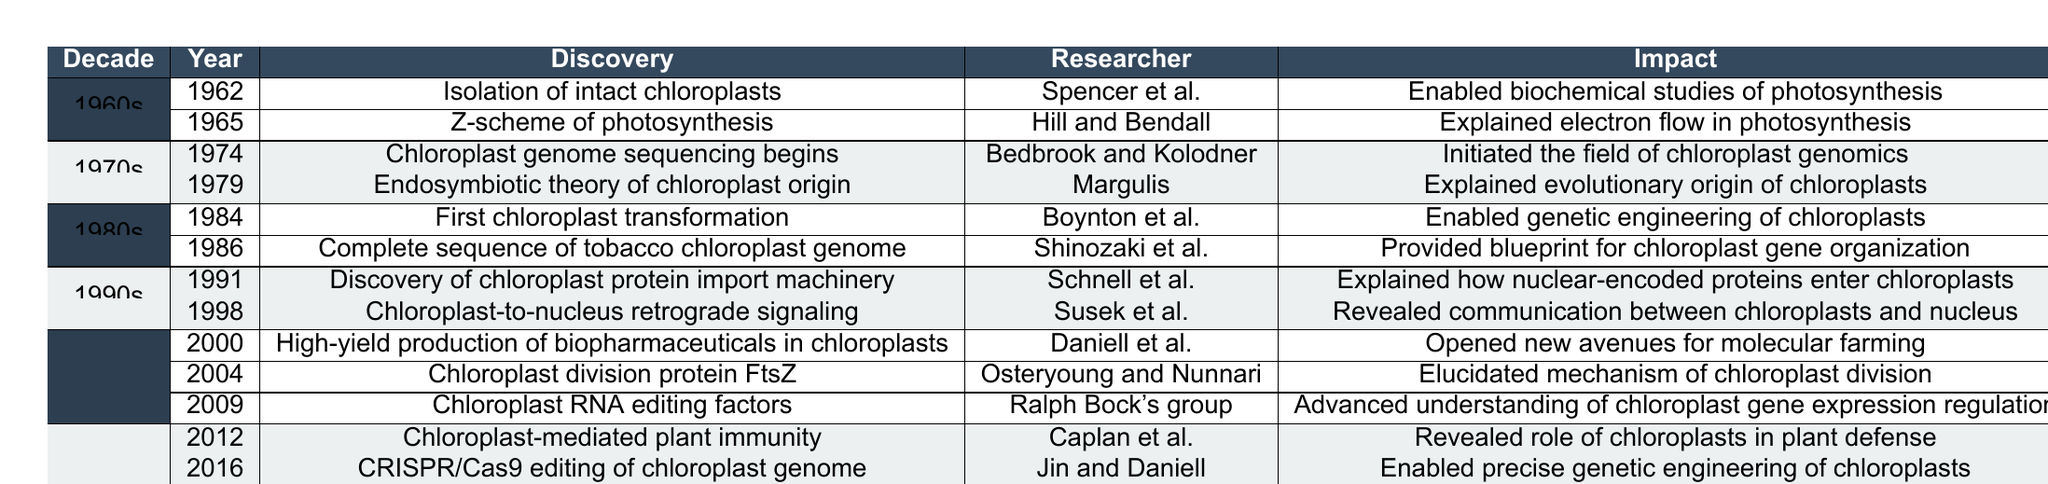What major discovery occurred in 1965 related to photosynthesis? The table lists that in 1965, the discovery of the "Z-scheme of photosynthesis" was made by Hill and Bendall. This discovery is significant as it explained electron flow in photosynthesis.
Answer: Z-scheme of photosynthesis Which researcher is associated with the first chloroplast transformation in 1984? Looking at the 1980s section of the table, the researcher associated with the first chloroplast transformation in 1984 is Boynton et al.
Answer: Boynton et al What was the impact of the discovery made in 1991? The 1991 discovery by Schnell et al. focused on the chloroplast protein import machinery, which explained how nuclear-encoded proteins enter chloroplasts.
Answer: Explained how nuclear-encoded proteins enter chloroplasts In which decade did chloroplast genome sequencing begin? According to the table, chloroplast genome sequencing began in the 1970s, specifically in the year 1974.
Answer: 1970s How many discoveries were made in the 2000s according to the table? In the 2000s section, there are three discoveries listed: 2000, 2004, and 2009. Therefore, the total number of discoveries made is 3.
Answer: 3 What is the relationship between the 2016 discovery and chloroplast genetic engineering? The 2016 discovery by Jin and Daniell involved "CRISPR/Cas9 editing of chloroplast genome," which enabled precise genetic engineering of chloroplasts. Hence, the relationship is that this discovery directly contributes to advances in genetic engineering.
Answer: Enables precise genetic engineering of chloroplasts Which discovery had the earliest impact according to the table? The table indicates that the discovery of "Isolation of intact chloroplasts" in 1962 by Spencer et al. had the earliest impact, enabling biochemical studies of photosynthesis.
Answer: Isolation of intact chloroplasts Between 1991 and 1998, which discovery had a broader implication in inter-organelle communication? The 1998 discovery of "Chloroplast-to-nucleus retrograde signaling" by Susek et al. had a broader implication in communication between chloroplasts and the nucleus compared to the 1991 discovery.
Answer: Chloroplast-to-nucleus retrograde signaling What is the significance of the "Synthetic chloroplast genome" discovery made in 2019? The 2019 discovery by Turmel et al. of a synthetic chloroplast genome opened possibilities for designing artificial chloroplasts, which has significant implications for synthetic biology and biotechnology.
Answer: Opened possibilities for designing artificial chloroplasts Was the discovery of the endosymbiotic theory of chloroplast origin confirmed by research in the 1970s? Yes, the table confirms that the "Endosymbiotic theory of chloroplast origin" was discovered by Margulis in 1979, confirming the evolutionary origin of chloroplasts.
Answer: Yes How does the impact of Ralph Bock's group's discovery in 2009 compare to the understanding of chloroplast genetics as a whole? The discovery in 2009 regarding "Chloroplast RNA editing factors" advanced the understanding of chloroplast gene expression regulation, which contributes to the overall understanding of chloroplast genetics by informing how gene expression is managed within chloroplasts.
Answer: Advanced understanding of chloroplast gene expression regulation 